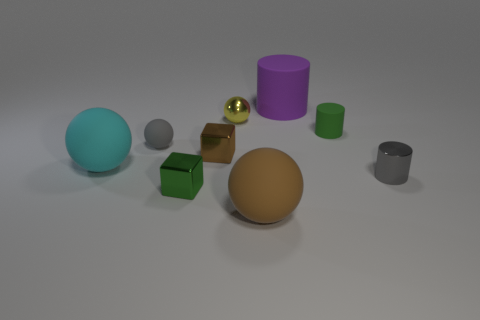What textures are visible among the objects in this scene? The scene presents a variety of textures, including matte surfaces on most of the objects, and a metallic sheen on the small golden sphere and the cubes. Are there any reflective surfaces in the image? Yes, the small golden sphere and the cubes have reflective surfaces that catch the light and surroundings. 